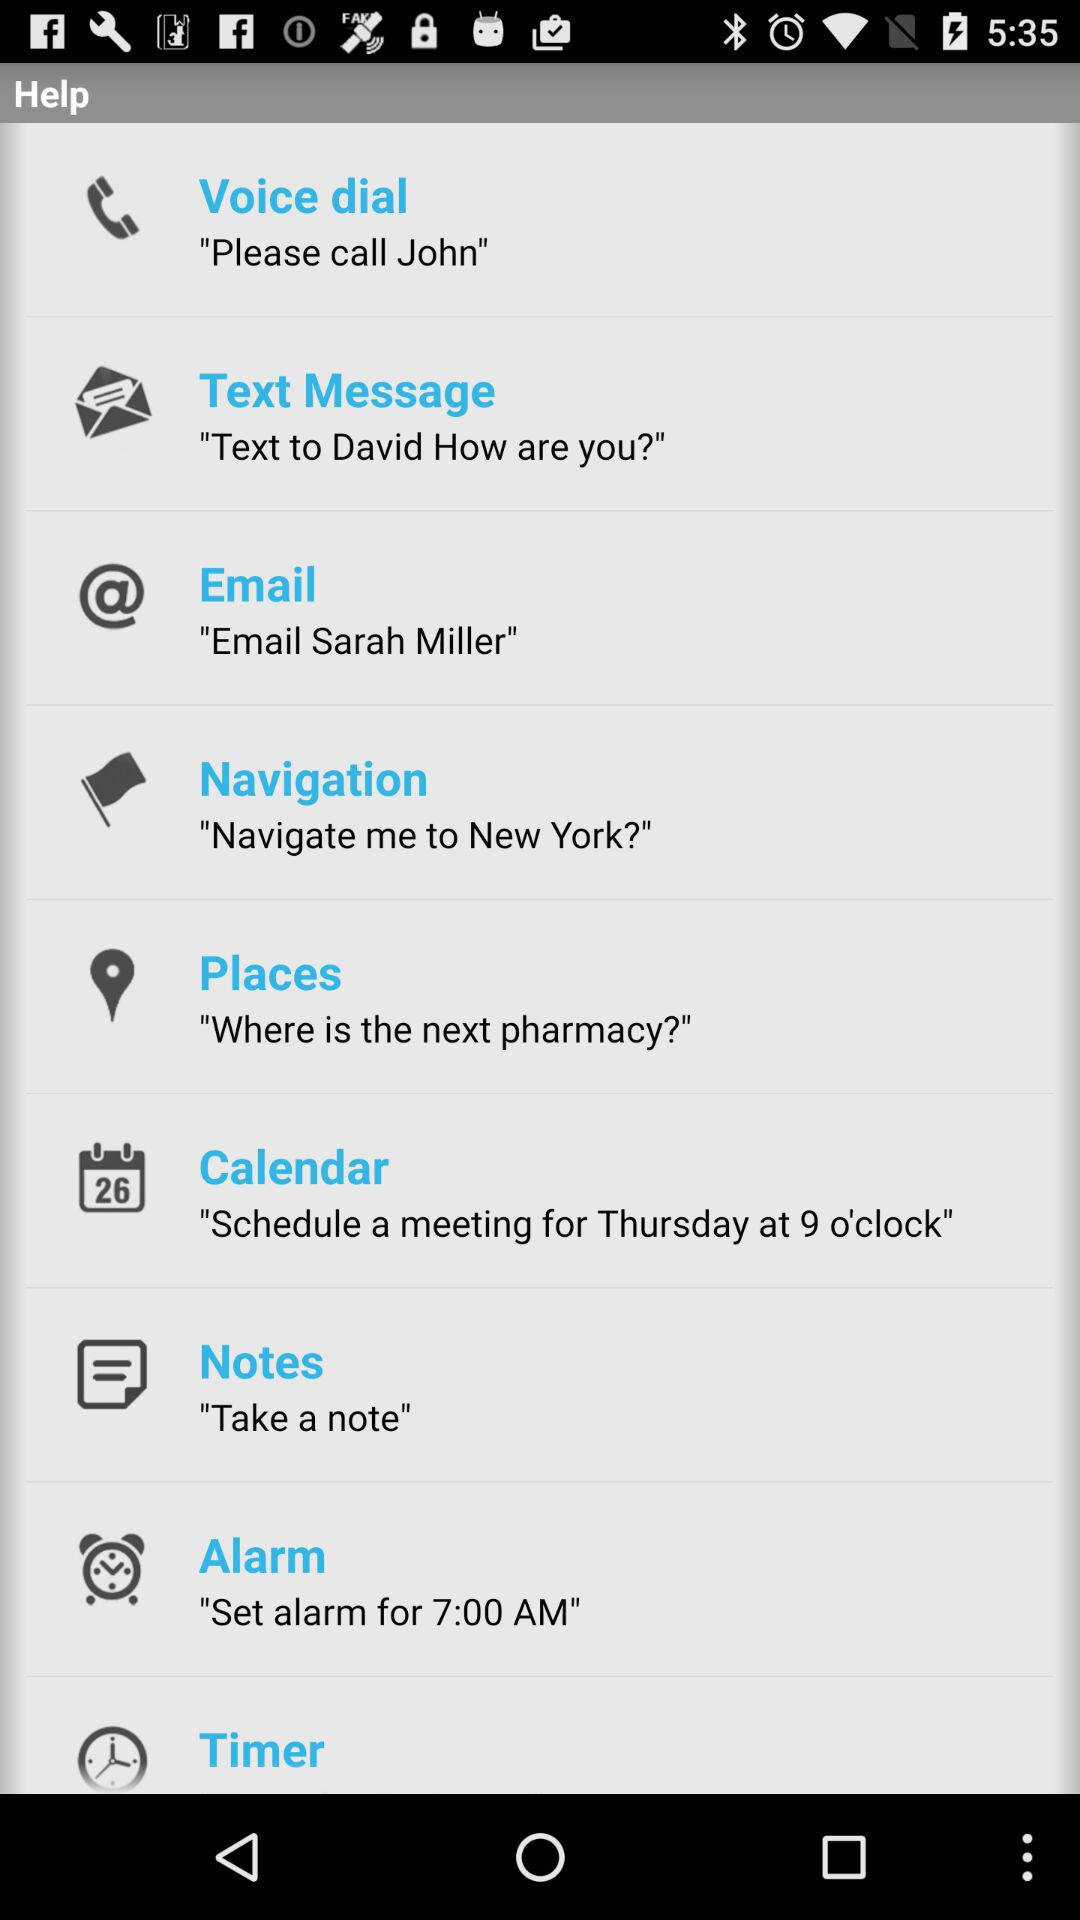What is the location given for navigation?
When the provided information is insufficient, respond with <no answer>. <no answer> 